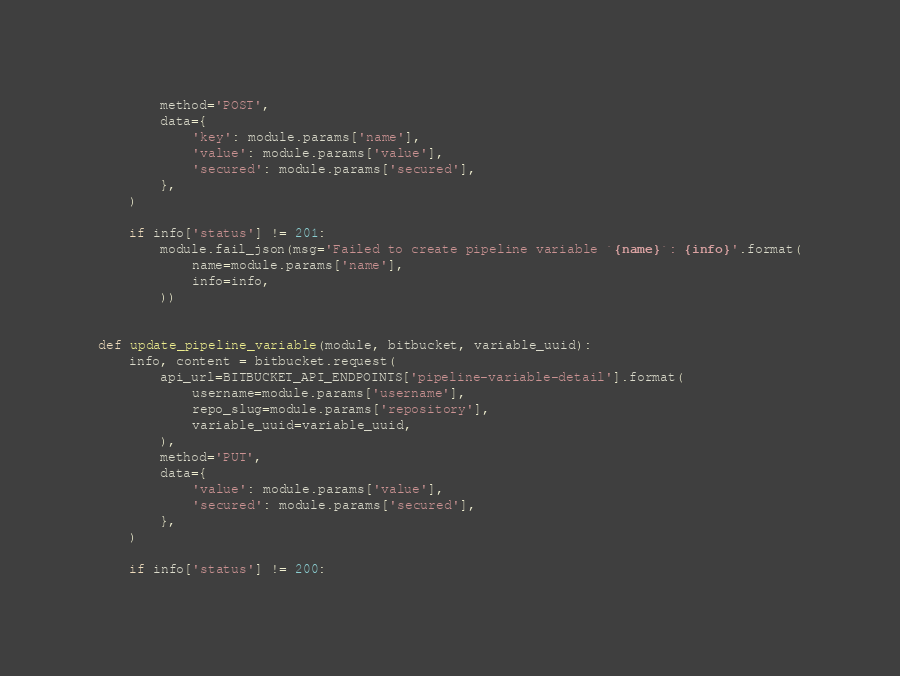<code> <loc_0><loc_0><loc_500><loc_500><_Python_>        method='POST',
        data={
            'key': module.params['name'],
            'value': module.params['value'],
            'secured': module.params['secured'],
        },
    )

    if info['status'] != 201:
        module.fail_json(msg='Failed to create pipeline variable `{name}`: {info}'.format(
            name=module.params['name'],
            info=info,
        ))


def update_pipeline_variable(module, bitbucket, variable_uuid):
    info, content = bitbucket.request(
        api_url=BITBUCKET_API_ENDPOINTS['pipeline-variable-detail'].format(
            username=module.params['username'],
            repo_slug=module.params['repository'],
            variable_uuid=variable_uuid,
        ),
        method='PUT',
        data={
            'value': module.params['value'],
            'secured': module.params['secured'],
        },
    )

    if info['status'] != 200:</code> 